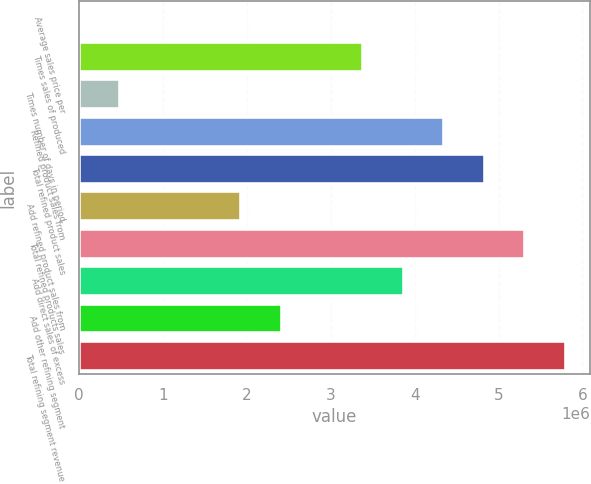Convert chart. <chart><loc_0><loc_0><loc_500><loc_500><bar_chart><fcel>Average sales price per<fcel>Times sales of produced<fcel>Times number of days in period<fcel>Refined product sales from<fcel>Total refined product sales<fcel>Add refined product sales from<fcel>Total refined products sales<fcel>Add direct sales of excess<fcel>Add other refining segment<fcel>Total refining segment revenue<nl><fcel>74.06<fcel>3.38401e+06<fcel>483493<fcel>4.35085e+06<fcel>4.83427e+06<fcel>1.93375e+06<fcel>5.31769e+06<fcel>3.86743e+06<fcel>2.41717e+06<fcel>5.80111e+06<nl></chart> 